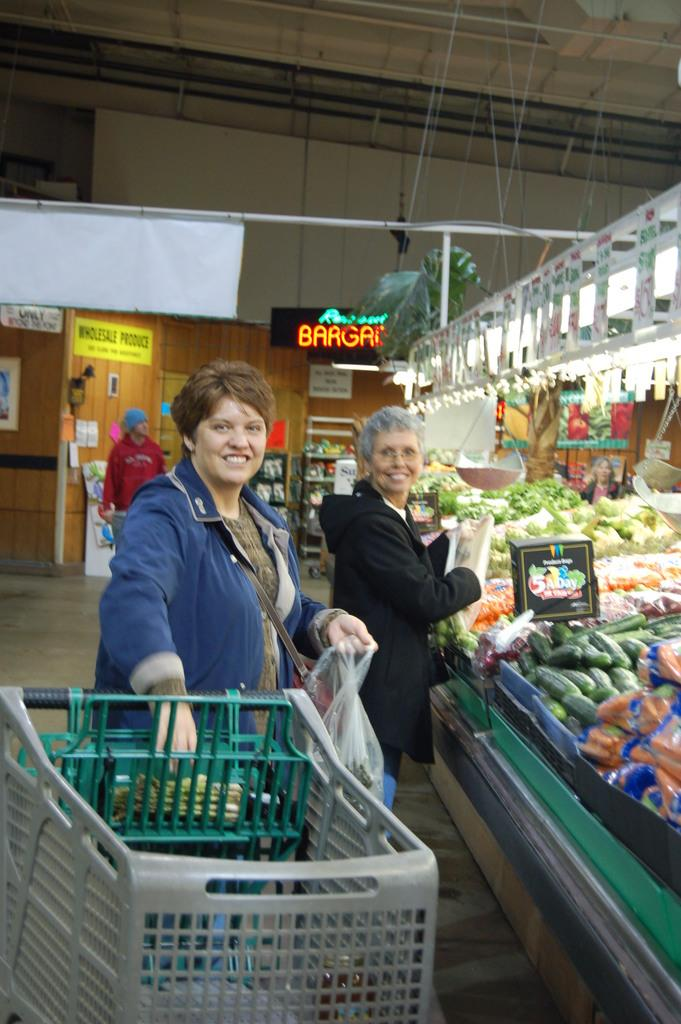<image>
Relay a brief, clear account of the picture shown. People shop at a store called Wholesale Produce. 